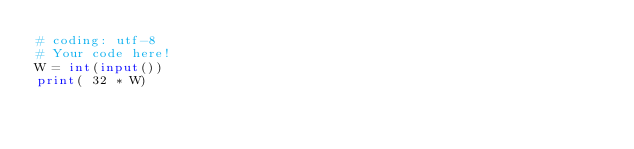Convert code to text. <code><loc_0><loc_0><loc_500><loc_500><_Python_># coding: utf-8
# Your code here!
W = int(input())
print( 32 * W)
</code> 